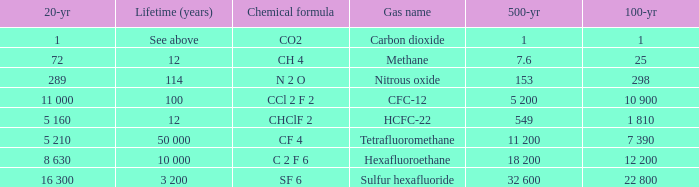What is the 500 year where 20 year is 289? 153.0. 